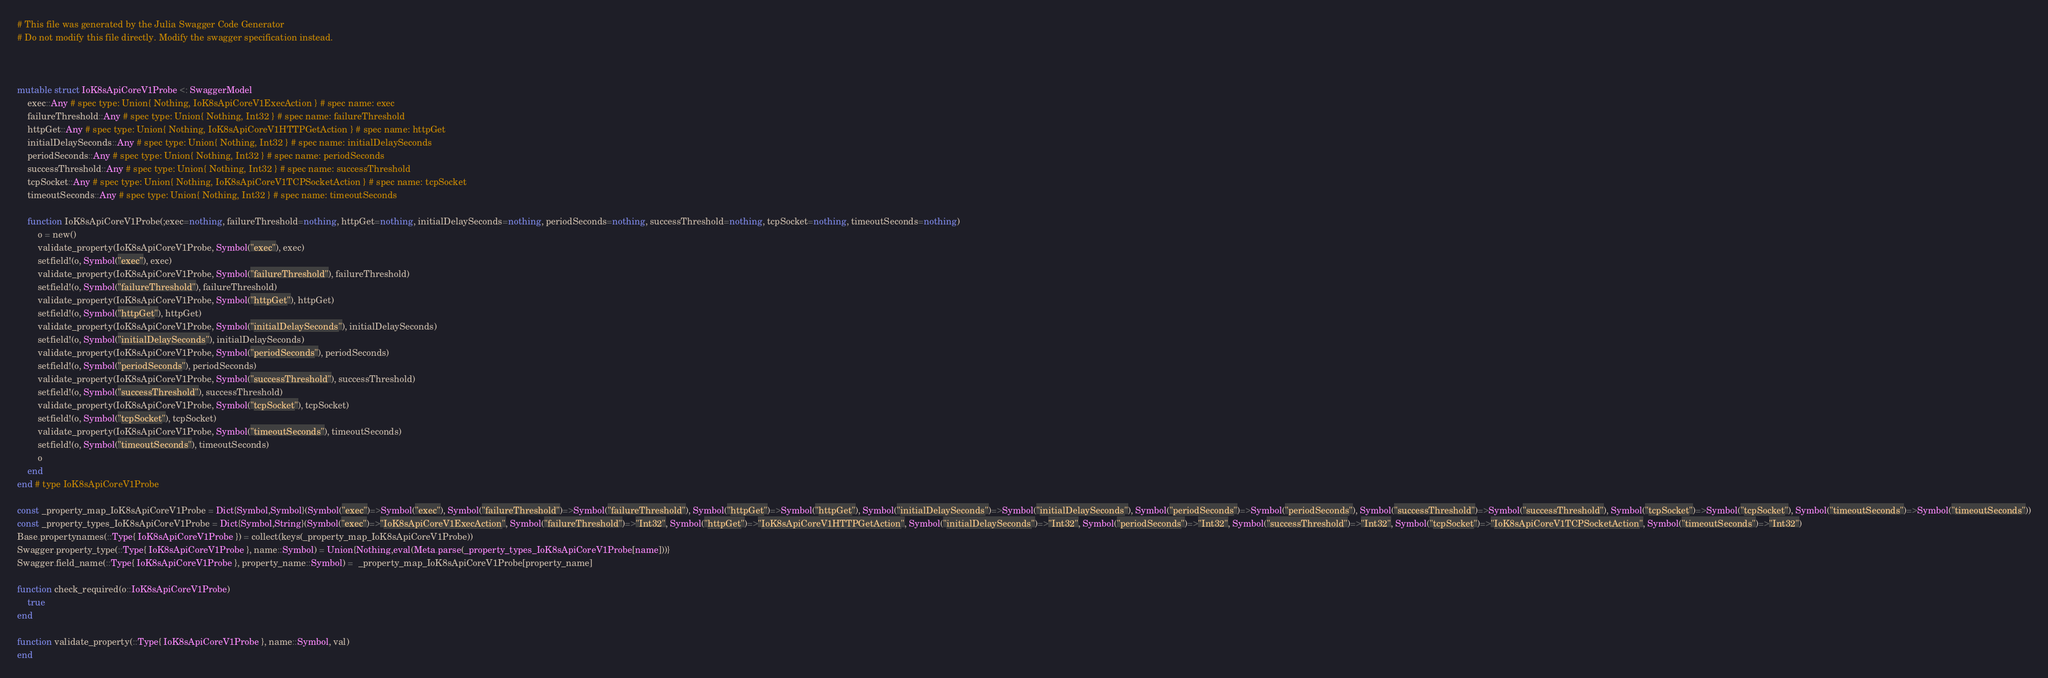<code> <loc_0><loc_0><loc_500><loc_500><_Julia_># This file was generated by the Julia Swagger Code Generator
# Do not modify this file directly. Modify the swagger specification instead.



mutable struct IoK8sApiCoreV1Probe <: SwaggerModel
    exec::Any # spec type: Union{ Nothing, IoK8sApiCoreV1ExecAction } # spec name: exec
    failureThreshold::Any # spec type: Union{ Nothing, Int32 } # spec name: failureThreshold
    httpGet::Any # spec type: Union{ Nothing, IoK8sApiCoreV1HTTPGetAction } # spec name: httpGet
    initialDelaySeconds::Any # spec type: Union{ Nothing, Int32 } # spec name: initialDelaySeconds
    periodSeconds::Any # spec type: Union{ Nothing, Int32 } # spec name: periodSeconds
    successThreshold::Any # spec type: Union{ Nothing, Int32 } # spec name: successThreshold
    tcpSocket::Any # spec type: Union{ Nothing, IoK8sApiCoreV1TCPSocketAction } # spec name: tcpSocket
    timeoutSeconds::Any # spec type: Union{ Nothing, Int32 } # spec name: timeoutSeconds

    function IoK8sApiCoreV1Probe(;exec=nothing, failureThreshold=nothing, httpGet=nothing, initialDelaySeconds=nothing, periodSeconds=nothing, successThreshold=nothing, tcpSocket=nothing, timeoutSeconds=nothing)
        o = new()
        validate_property(IoK8sApiCoreV1Probe, Symbol("exec"), exec)
        setfield!(o, Symbol("exec"), exec)
        validate_property(IoK8sApiCoreV1Probe, Symbol("failureThreshold"), failureThreshold)
        setfield!(o, Symbol("failureThreshold"), failureThreshold)
        validate_property(IoK8sApiCoreV1Probe, Symbol("httpGet"), httpGet)
        setfield!(o, Symbol("httpGet"), httpGet)
        validate_property(IoK8sApiCoreV1Probe, Symbol("initialDelaySeconds"), initialDelaySeconds)
        setfield!(o, Symbol("initialDelaySeconds"), initialDelaySeconds)
        validate_property(IoK8sApiCoreV1Probe, Symbol("periodSeconds"), periodSeconds)
        setfield!(o, Symbol("periodSeconds"), periodSeconds)
        validate_property(IoK8sApiCoreV1Probe, Symbol("successThreshold"), successThreshold)
        setfield!(o, Symbol("successThreshold"), successThreshold)
        validate_property(IoK8sApiCoreV1Probe, Symbol("tcpSocket"), tcpSocket)
        setfield!(o, Symbol("tcpSocket"), tcpSocket)
        validate_property(IoK8sApiCoreV1Probe, Symbol("timeoutSeconds"), timeoutSeconds)
        setfield!(o, Symbol("timeoutSeconds"), timeoutSeconds)
        o
    end
end # type IoK8sApiCoreV1Probe

const _property_map_IoK8sApiCoreV1Probe = Dict{Symbol,Symbol}(Symbol("exec")=>Symbol("exec"), Symbol("failureThreshold")=>Symbol("failureThreshold"), Symbol("httpGet")=>Symbol("httpGet"), Symbol("initialDelaySeconds")=>Symbol("initialDelaySeconds"), Symbol("periodSeconds")=>Symbol("periodSeconds"), Symbol("successThreshold")=>Symbol("successThreshold"), Symbol("tcpSocket")=>Symbol("tcpSocket"), Symbol("timeoutSeconds")=>Symbol("timeoutSeconds"))
const _property_types_IoK8sApiCoreV1Probe = Dict{Symbol,String}(Symbol("exec")=>"IoK8sApiCoreV1ExecAction", Symbol("failureThreshold")=>"Int32", Symbol("httpGet")=>"IoK8sApiCoreV1HTTPGetAction", Symbol("initialDelaySeconds")=>"Int32", Symbol("periodSeconds")=>"Int32", Symbol("successThreshold")=>"Int32", Symbol("tcpSocket")=>"IoK8sApiCoreV1TCPSocketAction", Symbol("timeoutSeconds")=>"Int32")
Base.propertynames(::Type{ IoK8sApiCoreV1Probe }) = collect(keys(_property_map_IoK8sApiCoreV1Probe))
Swagger.property_type(::Type{ IoK8sApiCoreV1Probe }, name::Symbol) = Union{Nothing,eval(Meta.parse(_property_types_IoK8sApiCoreV1Probe[name]))}
Swagger.field_name(::Type{ IoK8sApiCoreV1Probe }, property_name::Symbol) =  _property_map_IoK8sApiCoreV1Probe[property_name]

function check_required(o::IoK8sApiCoreV1Probe)
    true
end

function validate_property(::Type{ IoK8sApiCoreV1Probe }, name::Symbol, val)
end
</code> 